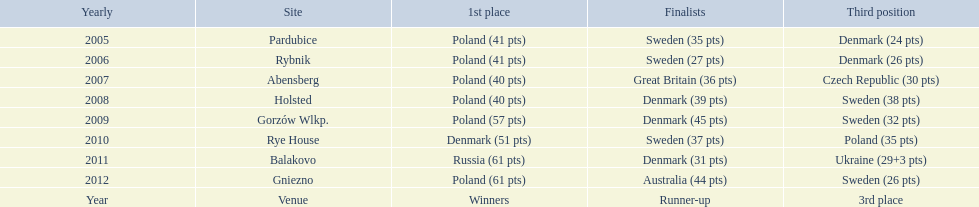In what years did denmark place in the top 3 in the team speedway junior world championship? 2005, 2006, 2008, 2009, 2010, 2011. What in what year did denmark come withing 2 points of placing higher in the standings? 2006. What place did denmark receive the year they missed higher ranking by only 2 points? 3rd place. 